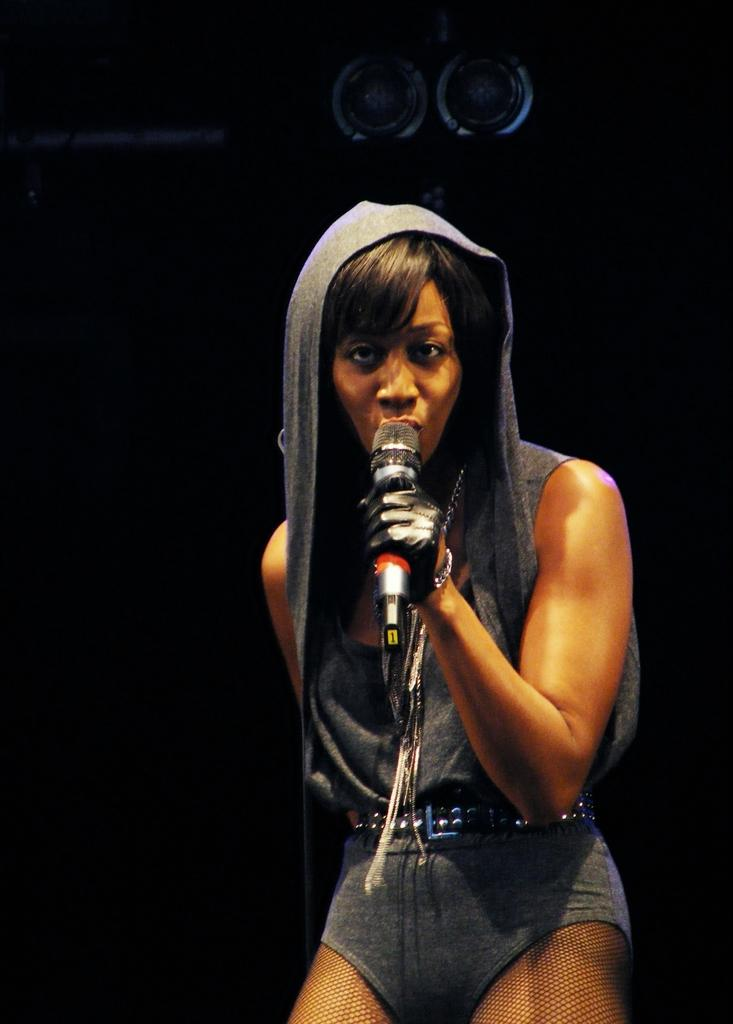Who is the main subject in the image? There is a woman in the image. What is the woman wearing? The woman is wearing a dress. What is the woman holding in the image? The woman is holding a microphone. What can be seen in the background of the image? There are speakers in the background of the image. Is the woman working on a plantation in the image? There is no indication of a plantation or any agricultural setting in the image. The woman is holding a microphone, which suggests she might be involved in a public speaking or performance activity. 